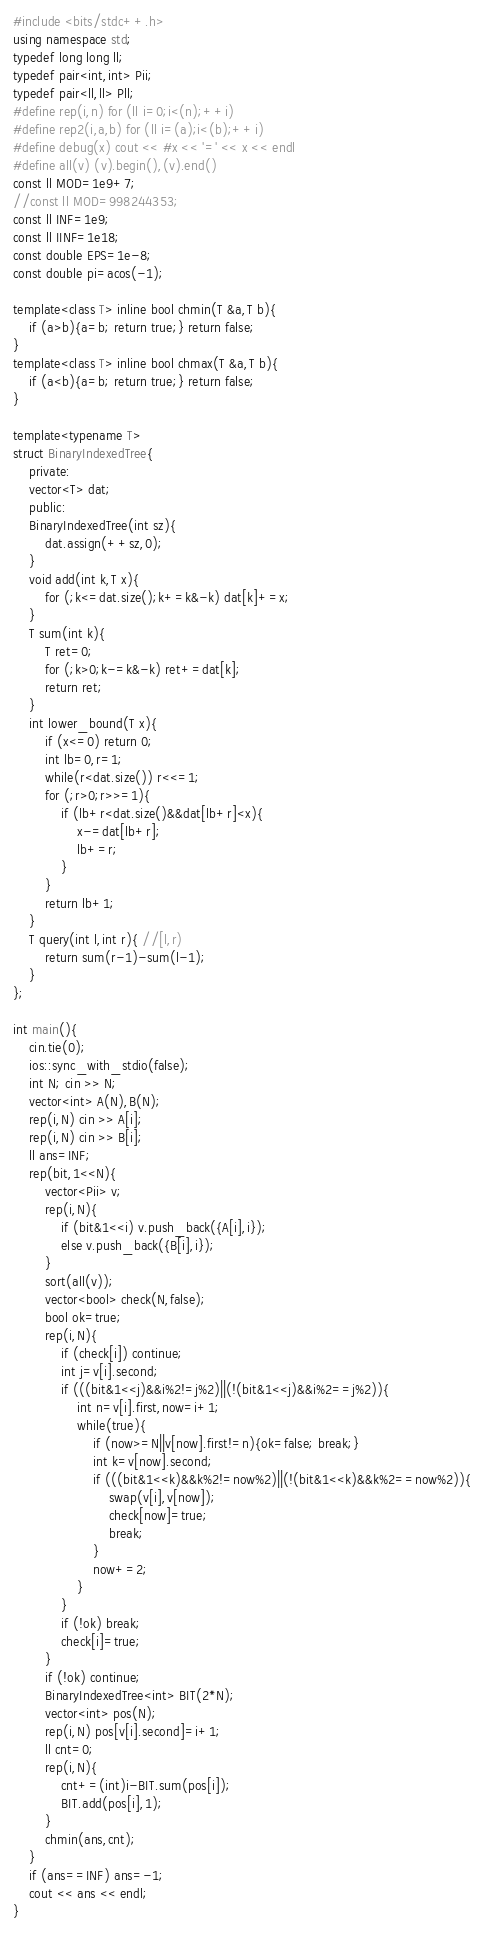Convert code to text. <code><loc_0><loc_0><loc_500><loc_500><_C++_>#include <bits/stdc++.h>
using namespace std;
typedef long long ll;
typedef pair<int,int> Pii;
typedef pair<ll,ll> Pll;
#define rep(i,n) for (ll i=0;i<(n);++i)
#define rep2(i,a,b) for (ll i=(a);i<(b);++i)
#define debug(x) cout << #x << '=' << x << endl
#define all(v) (v).begin(),(v).end()
const ll MOD=1e9+7;
//const ll MOD=998244353;
const ll INF=1e9;
const ll IINF=1e18;
const double EPS=1e-8;
const double pi=acos(-1);

template<class T> inline bool chmin(T &a,T b){
    if (a>b){a=b; return true;} return false;
}
template<class T> inline bool chmax(T &a,T b){
    if (a<b){a=b; return true;} return false;
}

template<typename T>
struct BinaryIndexedTree{
    private:
    vector<T> dat;
    public:
    BinaryIndexedTree(int sz){
        dat.assign(++sz,0);
    }
    void add(int k,T x){
        for (;k<=dat.size();k+=k&-k) dat[k]+=x;
    }
    T sum(int k){
        T ret=0;
        for (;k>0;k-=k&-k) ret+=dat[k];
        return ret;
    }
    int lower_bound(T x){
        if (x<=0) return 0;
        int lb=0,r=1;
        while(r<dat.size()) r<<=1;
        for (;r>0;r>>=1){
            if (lb+r<dat.size()&&dat[lb+r]<x){
                x-=dat[lb+r];
                lb+=r;
            }
        }
        return lb+1;
    }
    T query(int l,int r){ //[l,r)
        return sum(r-1)-sum(l-1);
    }
};

int main(){
    cin.tie(0);
    ios::sync_with_stdio(false);
    int N; cin >> N;
    vector<int> A(N),B(N);
    rep(i,N) cin >> A[i];
    rep(i,N) cin >> B[i];
    ll ans=INF;
    rep(bit,1<<N){
        vector<Pii> v;
        rep(i,N){
            if (bit&1<<i) v.push_back({A[i],i});
            else v.push_back({B[i],i});
        }
        sort(all(v));
        vector<bool> check(N,false);
        bool ok=true;
        rep(i,N){
            if (check[i]) continue;
            int j=v[i].second;
            if (((bit&1<<j)&&i%2!=j%2)||(!(bit&1<<j)&&i%2==j%2)){
                int n=v[i].first,now=i+1;
                while(true){
                    if (now>=N||v[now].first!=n){ok=false; break;}
                    int k=v[now].second;
                    if (((bit&1<<k)&&k%2!=now%2)||(!(bit&1<<k)&&k%2==now%2)){
                        swap(v[i],v[now]);
                        check[now]=true;
                        break;
                    }
                    now+=2;
                }
            }
            if (!ok) break;
            check[i]=true;
        }
        if (!ok) continue;
        BinaryIndexedTree<int> BIT(2*N);
        vector<int> pos(N);
        rep(i,N) pos[v[i].second]=i+1;
        ll cnt=0;
        rep(i,N){
            cnt+=(int)i-BIT.sum(pos[i]);
            BIT.add(pos[i],1);
        }
        chmin(ans,cnt);
    }
    if (ans==INF) ans=-1;
    cout << ans << endl;
}</code> 